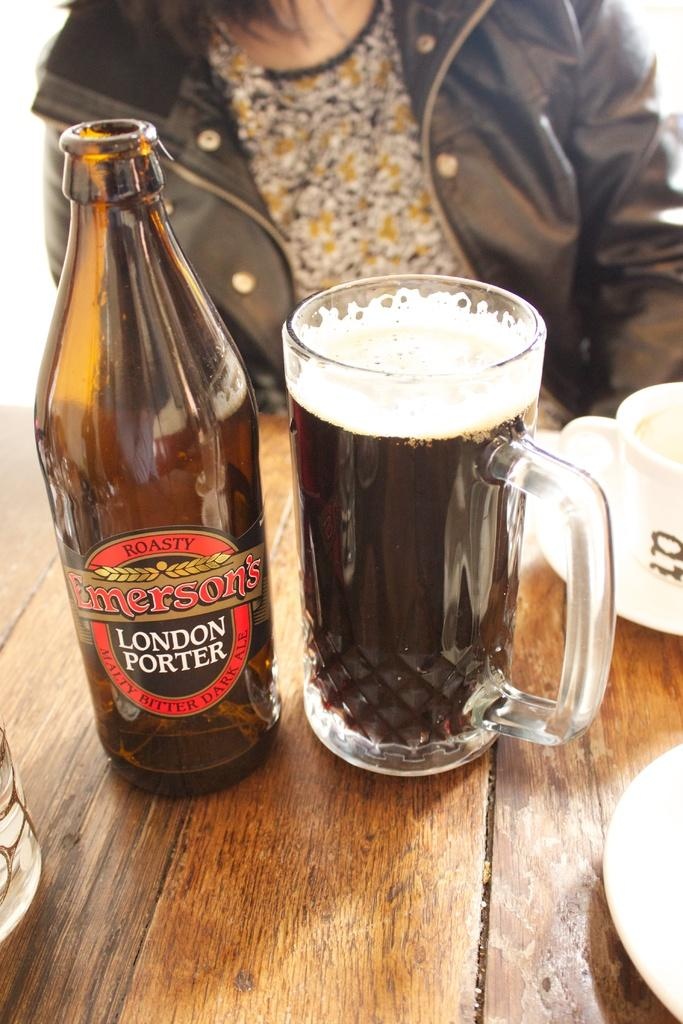Provide a one-sentence caption for the provided image. A mug containing a dark bitter ale called London Porter by Emerson's. 